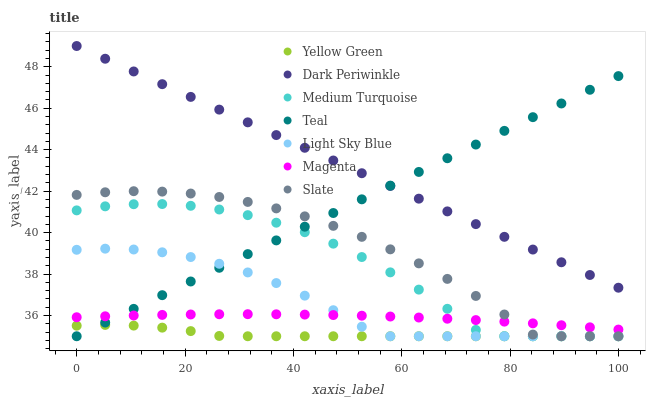Does Yellow Green have the minimum area under the curve?
Answer yes or no. Yes. Does Dark Periwinkle have the maximum area under the curve?
Answer yes or no. Yes. Does Slate have the minimum area under the curve?
Answer yes or no. No. Does Slate have the maximum area under the curve?
Answer yes or no. No. Is Teal the smoothest?
Answer yes or no. Yes. Is Medium Turquoise the roughest?
Answer yes or no. Yes. Is Yellow Green the smoothest?
Answer yes or no. No. Is Yellow Green the roughest?
Answer yes or no. No. Does Medium Turquoise have the lowest value?
Answer yes or no. Yes. Does Magenta have the lowest value?
Answer yes or no. No. Does Dark Periwinkle have the highest value?
Answer yes or no. Yes. Does Slate have the highest value?
Answer yes or no. No. Is Yellow Green less than Dark Periwinkle?
Answer yes or no. Yes. Is Dark Periwinkle greater than Magenta?
Answer yes or no. Yes. Does Yellow Green intersect Medium Turquoise?
Answer yes or no. Yes. Is Yellow Green less than Medium Turquoise?
Answer yes or no. No. Is Yellow Green greater than Medium Turquoise?
Answer yes or no. No. Does Yellow Green intersect Dark Periwinkle?
Answer yes or no. No. 